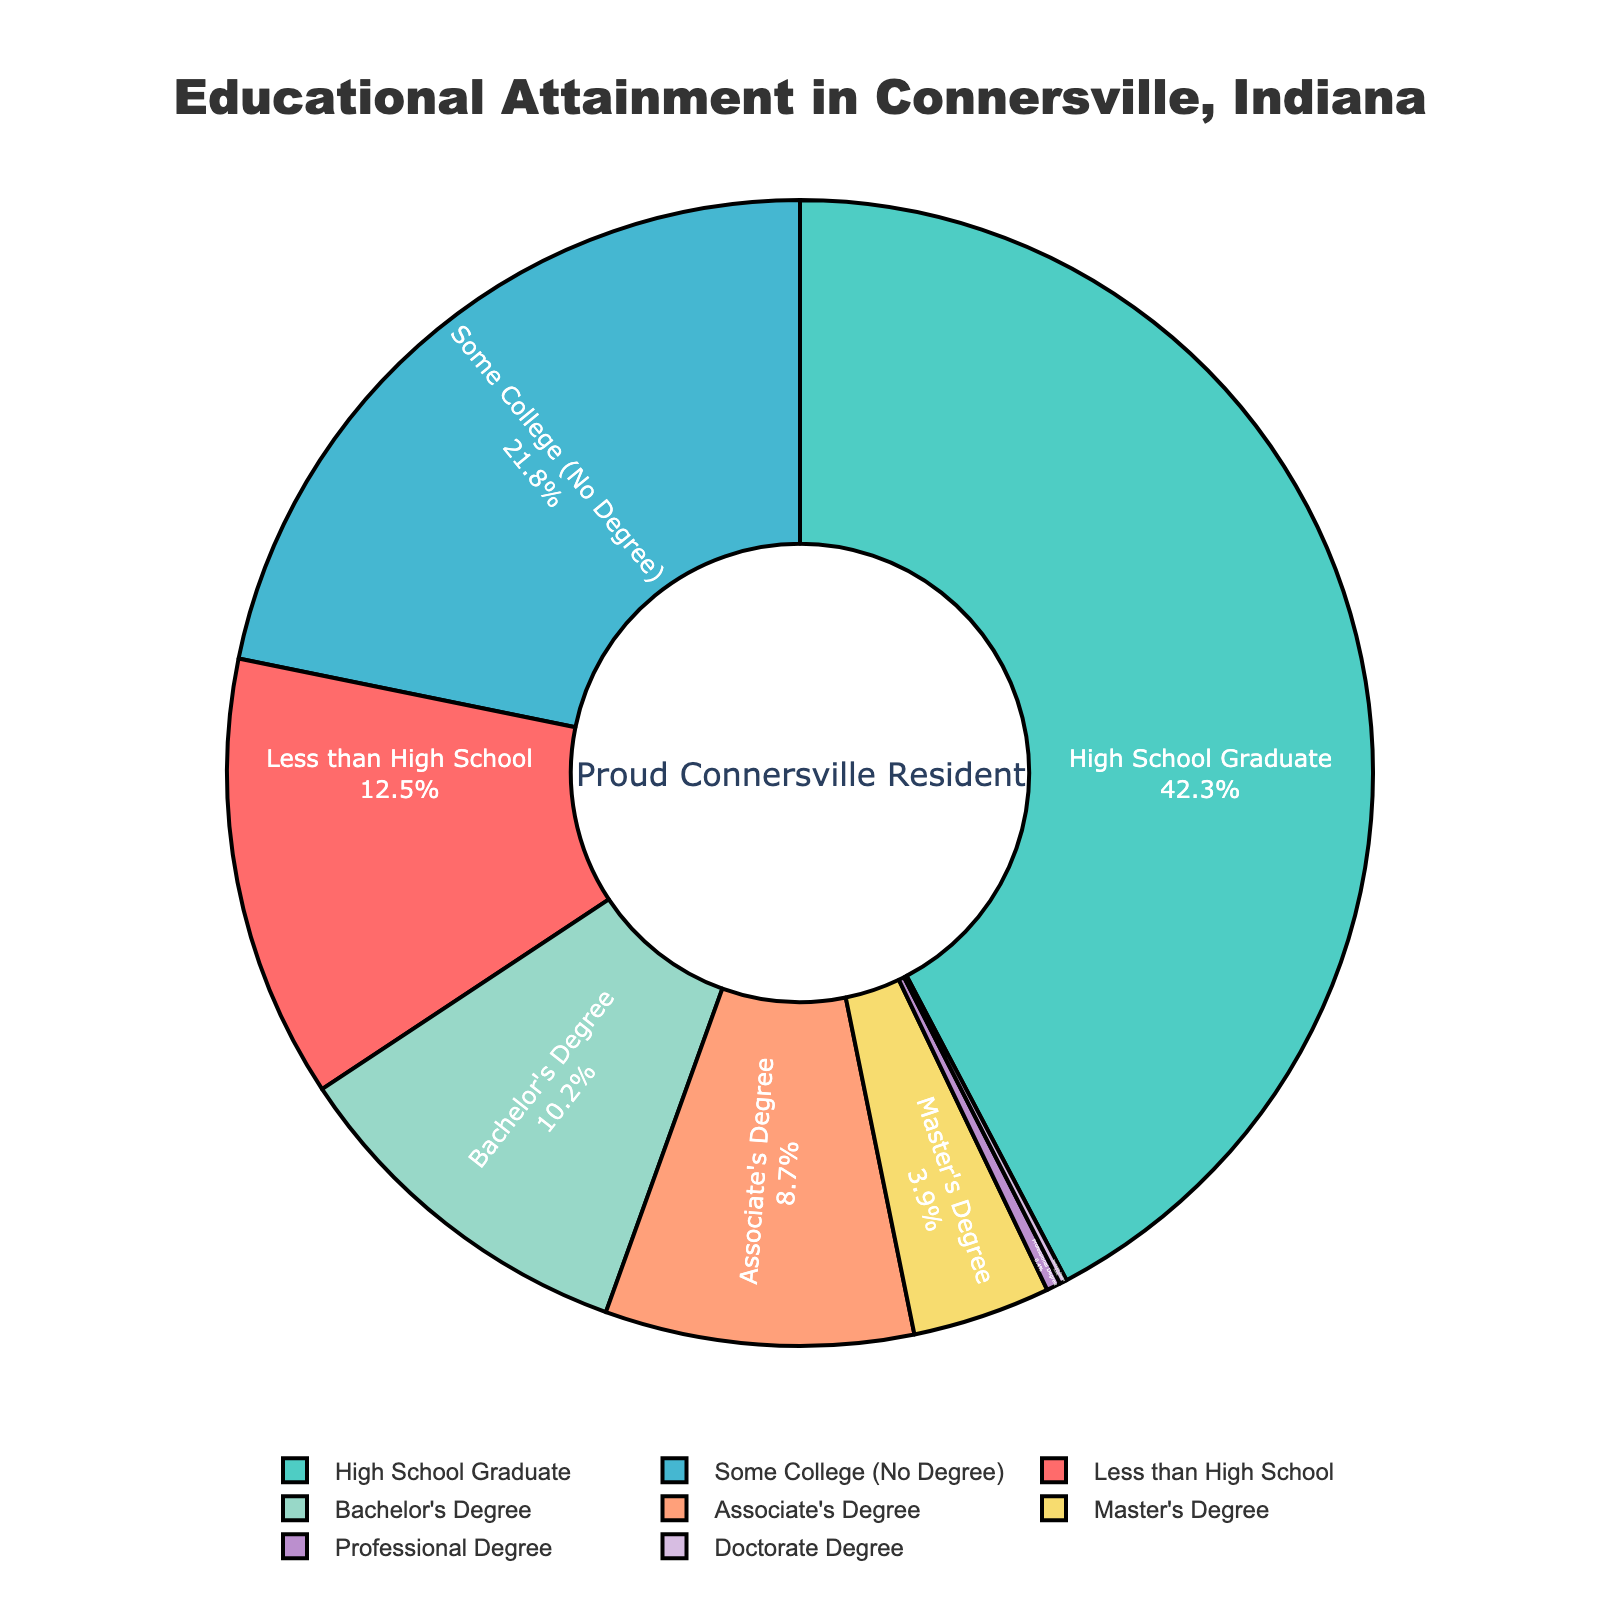Which educational level has the highest percentage? The pie chart shows that the "High School Graduate" segment takes the largest portion of the chart. By looking at the labels associated with each segment, the "High School Graduate" has 42.3%, which is the highest percentage.
Answer: High School Graduate What is the combined percentage of people with a Bachelor’s Degree and higher (i.e., Bachelor’s, Master’s, Professional, and Doctorate Degrees)? To find the combined percentage, sum the percentages of all the higher degrees: 10.2% (Bachelor’s) + 3.9% (Master’s) + 0.4% (Professional) + 0.2% (Doctorate) = 14.7%.
Answer: 14.7% Which two educational levels are closest in percentage, and what are their values? By comparing the percentages on the chart, the closest two segments are "Master's Degree" and "Associate's Degree". Master's Degree is 3.9%, and Associate's Degree is 8.7%, with their difference being 4.8%.
Answer: Master's Degree (3.9%) and Associate's Degree (8.7%) How does the percentage of people with "Some College (No Degree)" compare to those with an Associate's Degree? The chart shows "Some College (No Degree)" is 21.8%, and "Associate's Degree" is 8.7%. By subtracting, 21.8% - 8.7% = 13.1%, showing a higher percentage for "Some College (No Degree)".
Answer: "Some College (No Degree)" is 13.1% higher What educational level has the smallest representation in the chart, and what is its percentage? By observing the pie chart, the smallest segment is the "Doctorate Degree" part, with a percentage of 0.2%.
Answer: Doctorate Degree What is the total percentage of people who have at least "Some College (No Degree)"? Calculate total by summing percentages: 21.8% (Some College) + 8.7% (Associate's) + 10.2% (Bachelor's) + 3.9% (Master's) + 0.4% (Professional) + 0.2% (Doctorate) = 45.2%.
Answer: 45.2% Which segment appears in red, and what is its percentage? Referring to the visual representation and the color used for each segment, "Less than High School" appears in red, with a percentage of 12.5%.
Answer: Less than High School (12.5%) What is the difference in percentage between people with "High School Graduate" and "Bachelor's Degree"? The "High School Graduate" percentage is 42.3%, and "Bachelor's Degree" is 10.2%. The difference is 42.3% - 10.2% = 32.1%.
Answer: 32.1% What percentage of people have completed a degree beyond high school (i.e., Associate’s, Bachelor’s, Master’s, Professional, and Doctorate Degrees)? By summing these degrees: 8.7% (Associate’s) + 10.2% (Bachelor’s) + 3.9% (Master’s) + 0.4% (Professional) + 0.2% (Doctorate) = 23.4%.
Answer: 23.4% Compare the combined percentage of "Less than High School" and "High School Graduate" with the combined percentage of all higher education levels. Which is greater? The combined percentage of "Less than High School" and "High School Graduate" is 12.5% + 42.3% = 54.8%. The combined percentage of higher education levels is 23.4%. Hence, 54.8% is greater than 23.4%.
Answer: 54.8% is greater 